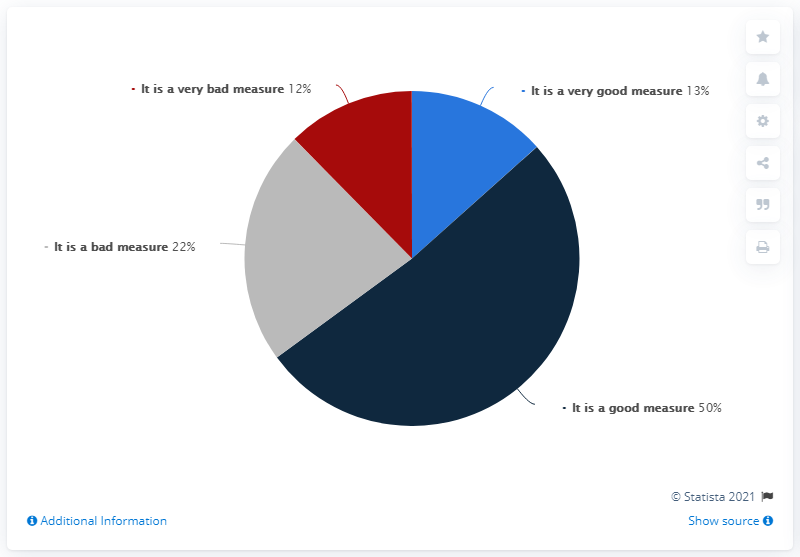Give some essential details in this illustration. The color navy blue has the highest share. The total of shares other than the highest is 47. 